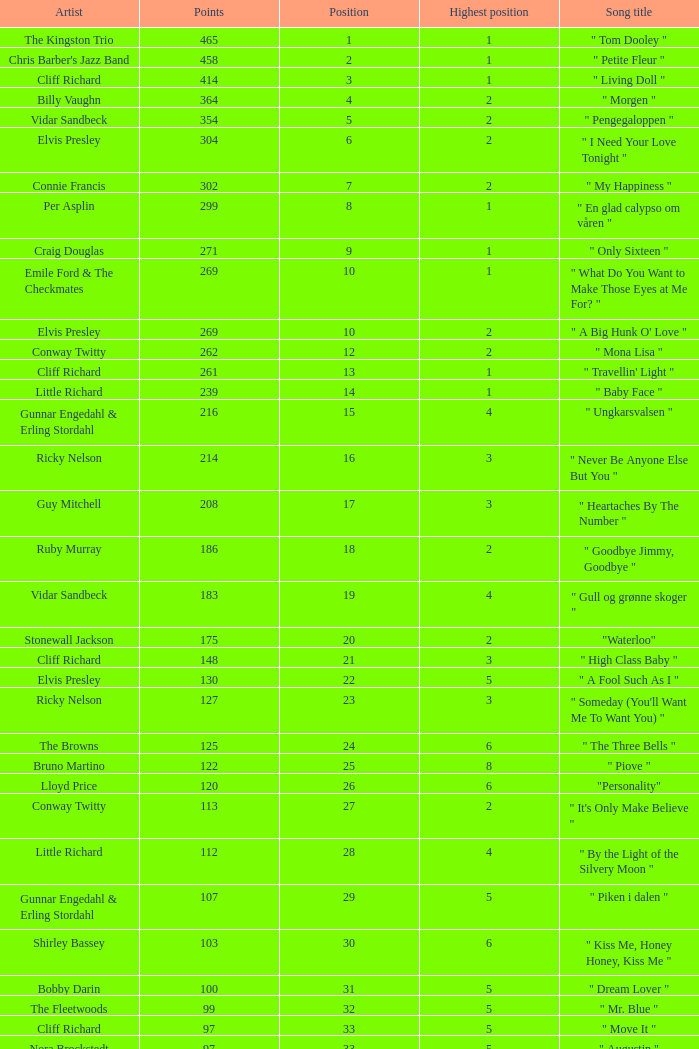What is the nme of the song performed by billy vaughn? " Morgen ". 